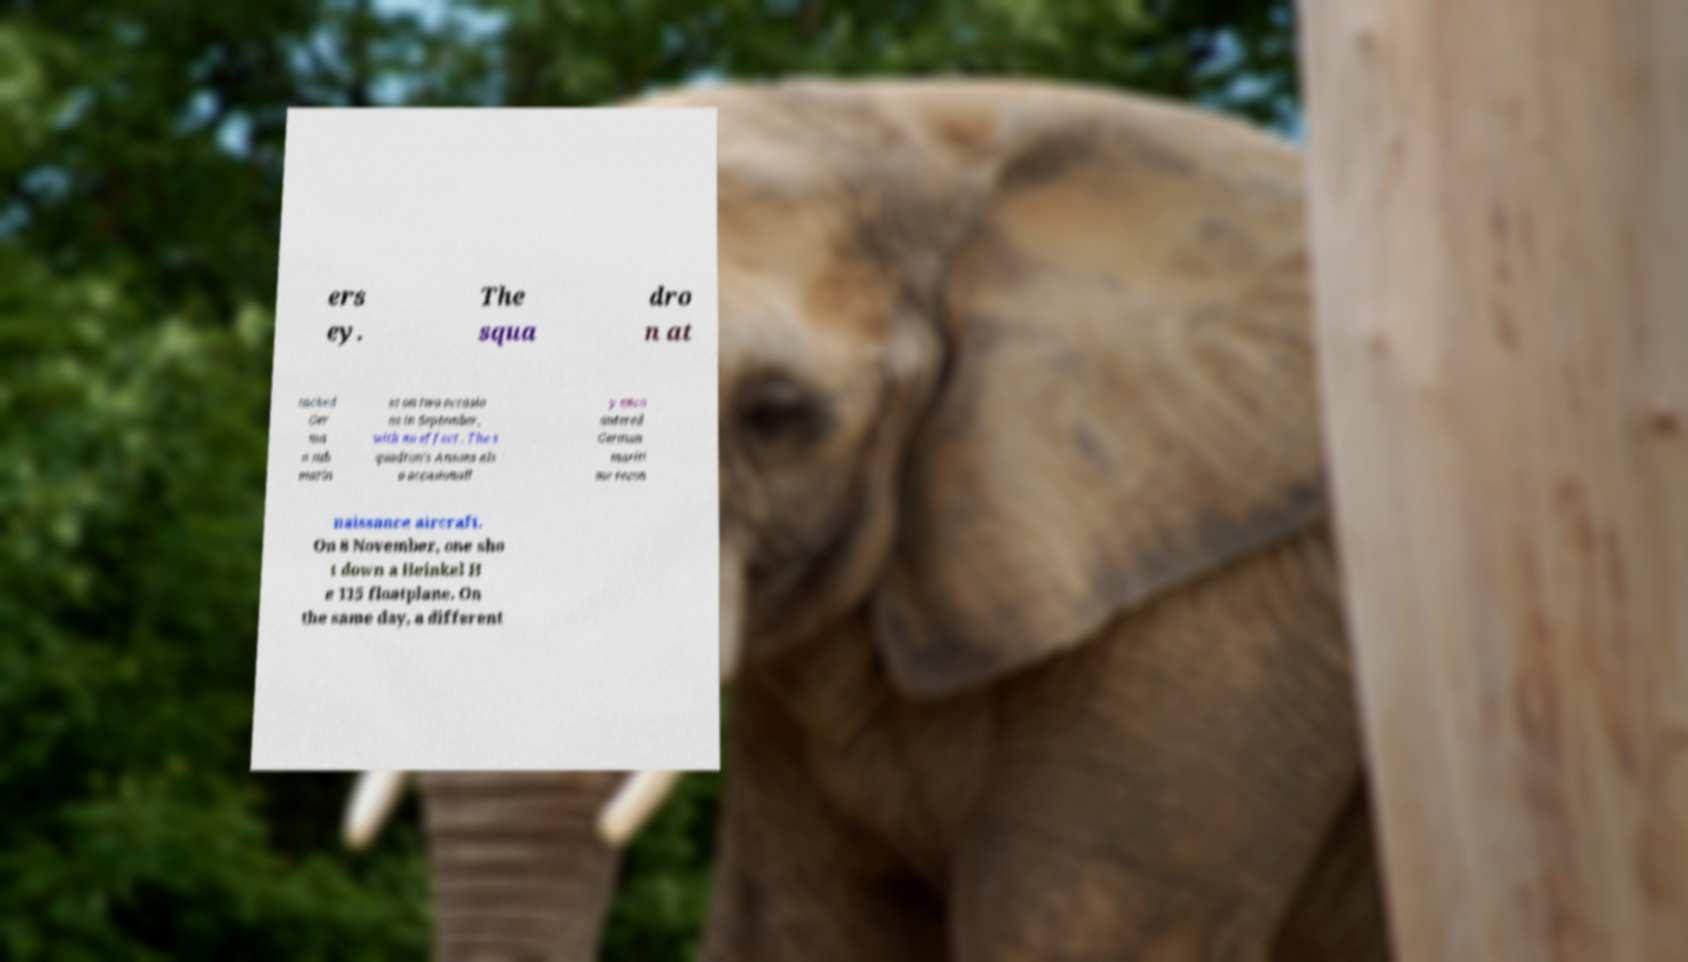Could you extract and type out the text from this image? ers ey. The squa dro n at tacked Ger ma n sub marin es on two occasio ns in September, with no effect . The s quadron's Ansons als o occasionall y enco untered German mariti me recon naissance aircraft. On 8 November, one sho t down a Heinkel H e 115 floatplane. On the same day, a different 